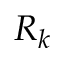<formula> <loc_0><loc_0><loc_500><loc_500>R _ { k }</formula> 